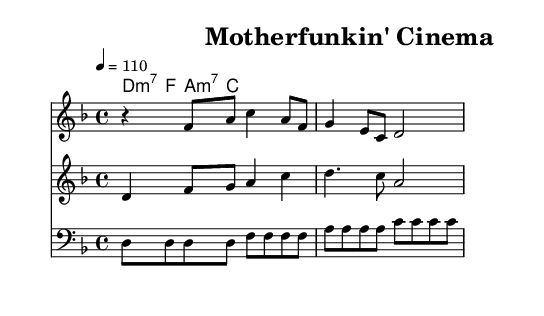What is the key signature of this music? The key signature has two flats, indicating the music is set in D minor. This can be determined by the presence of the B flat and E flat notes.
Answer: D minor What is the time signature of this piece? The time signature is 4/4, which can be identified by looking at the notation at the beginning of the music. It indicates that there are four beats per measure.
Answer: 4/4 What is the tempo marking of the score? The tempo marking is 110 beats per minute, which is indicated by the number next to the word "tempo" at the beginning. This denotes the speed of the music.
Answer: 110 What chord is played in the first measure? The chord played in the first measure is D minor 7. This can be concluded by looking at the chord names above the staff and recognizing the standard shorthand notation for this chord.
Answer: D minor 7 How many measures are in the vocal melody? The vocal melody consists of three measures. By counting the groups of notes separated by vertical lines (bar lines), we find there are three distinct measures in the vocal line.
Answer: 3 What type of instrument plays the bass line? The bass line is played by a bass instrument, as indicated by the clef labeled "bass" at the beginning of that staff. This clef signifies that the notes are intended for lower-pitched instruments.
Answer: Bass What musical elements characterizes the funk genre in this piece? The piece features syncopation and strong rhythms, typical of funk music, which can be inferred from the rhythmic pattern in the bass and brass sections that emphasizes off-beats.
Answer: Syncopation 